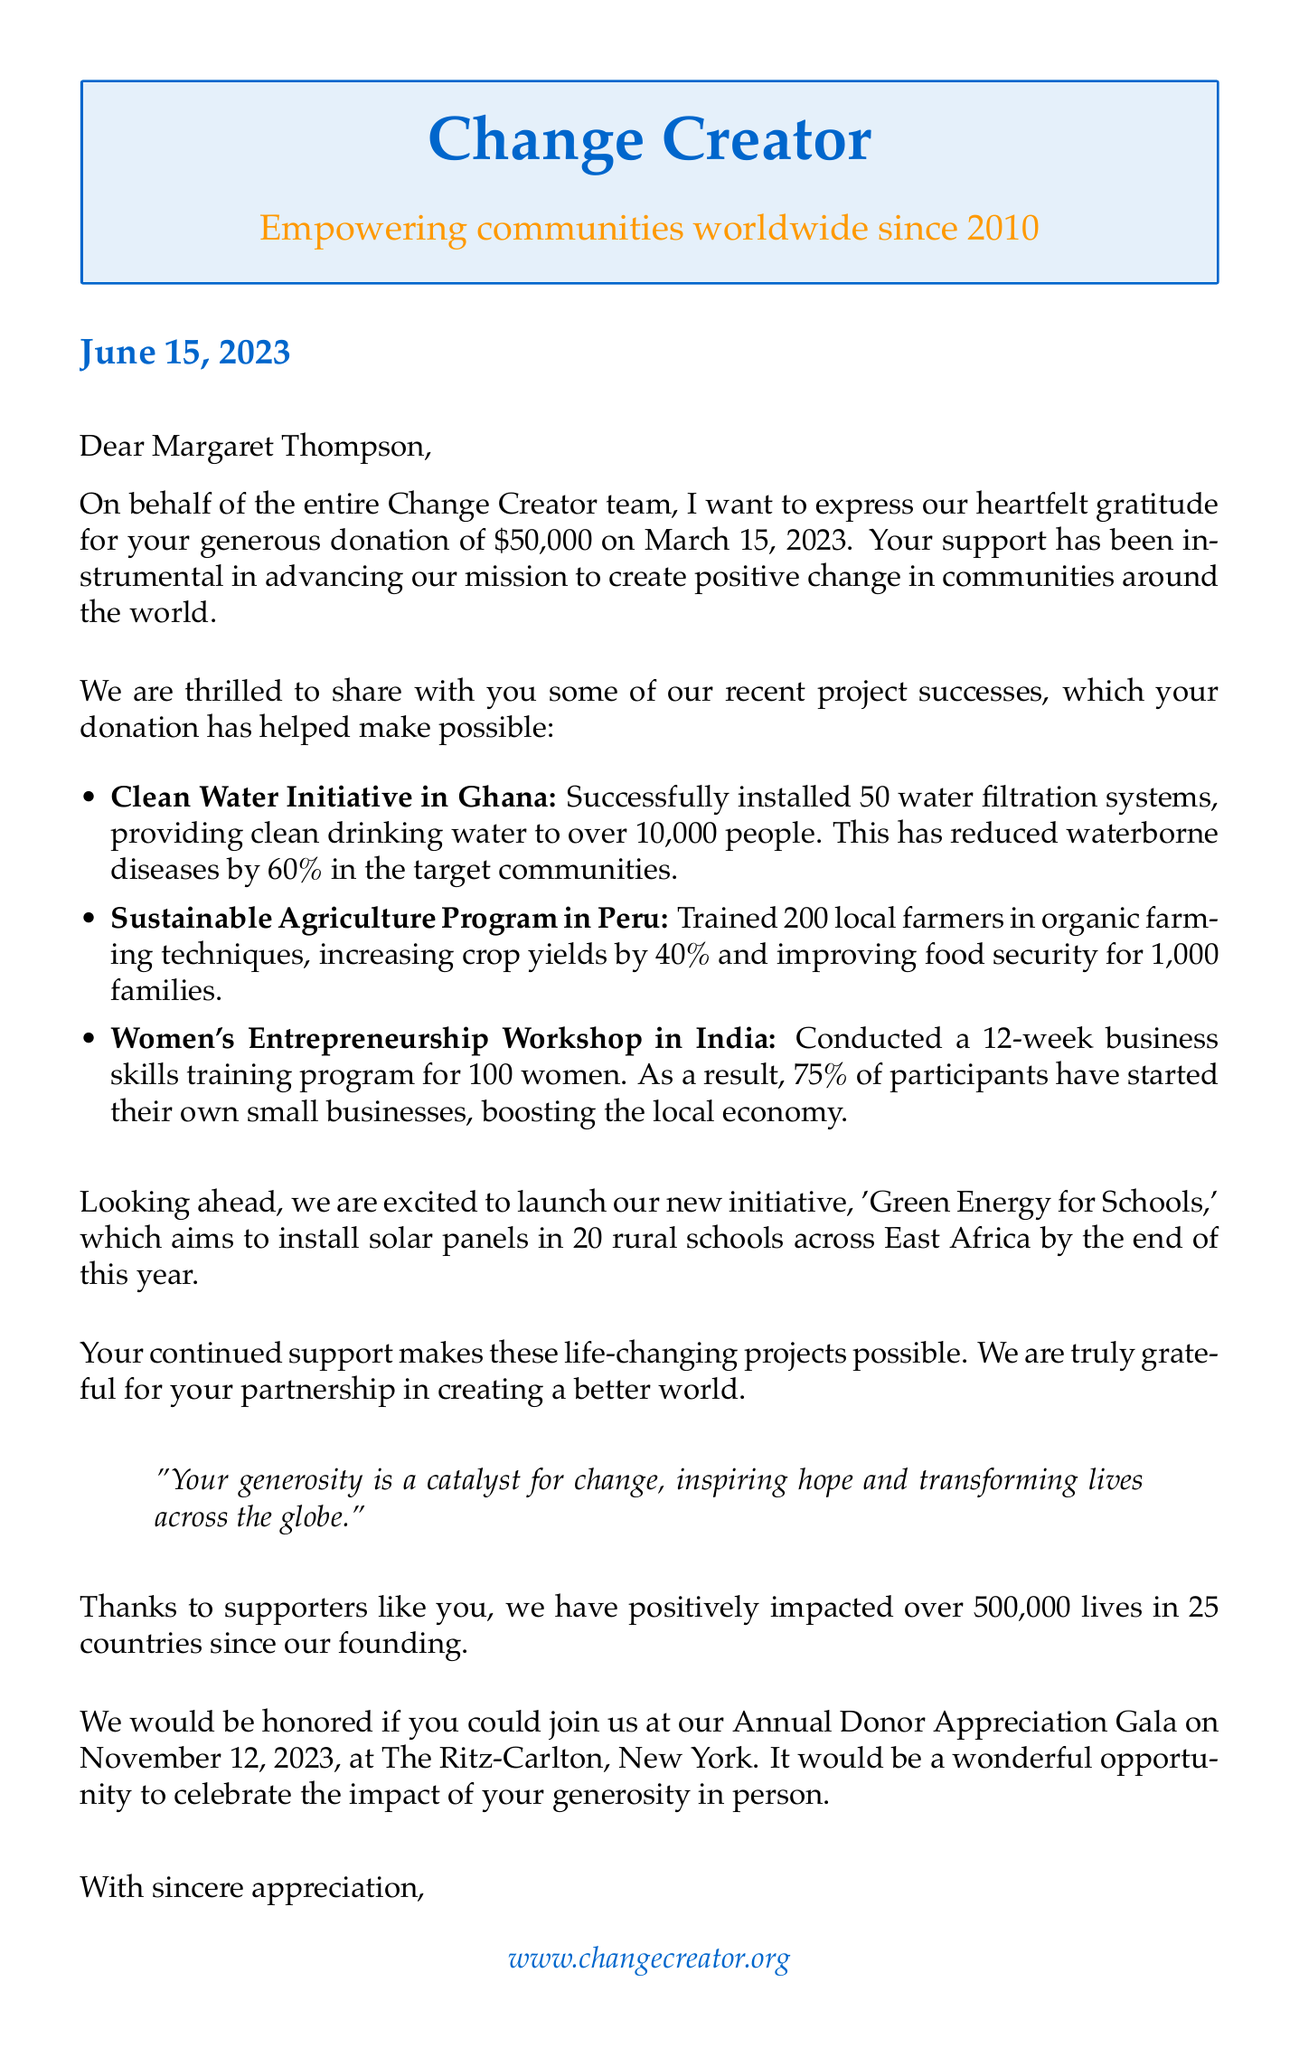What is the donor's name? The donor's name is mentioned in the greeting of the letter.
Answer: Margaret Thompson What was the donation amount? The donation amount is specified in the opening paragraph of the letter.
Answer: $50,000 When was the donation made? The date of the donation is included in the letter.
Answer: March 15, 2023 How many people benefited from the Clean Water Initiative in Ghana? This information is provided in the update section regarding the project.
Answer: over 10,000 people What was the impact of the Sustainable Agriculture Program in Peru? The impact is detailed in the project update section.
Answer: Improved food security for 1,000 families What is the upcoming event mentioned in the letter? The upcoming event is stated in the document towards the end.
Answer: Annual Donor Appreciation Gala What percentage of women started their own businesses after the Women's Entrepreneurship Workshop in India? This statistic is given in the project update section.
Answer: 75% What is the mission of Change Creator? The mission is stated in the organization info part of the letter.
Answer: To empower communities worldwide through sustainable development projects and social entrepreneurship What initiative is Change Creator planning to launch? The future plans section indicates the new initiative.
Answer: Green Energy for Schools 